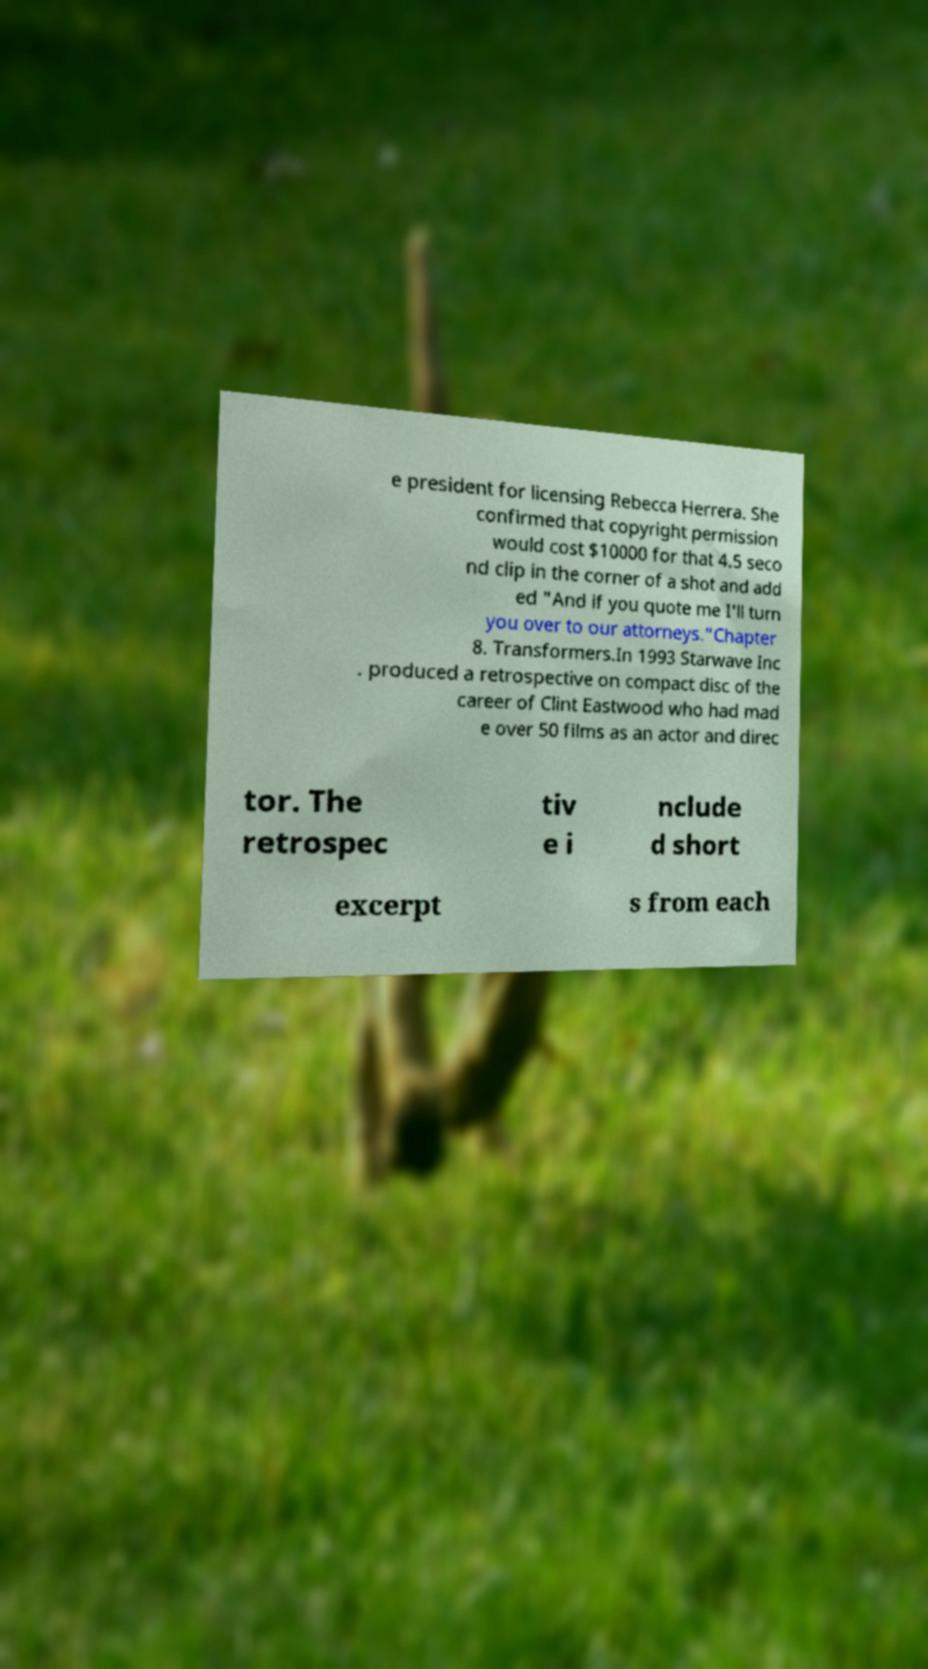Can you accurately transcribe the text from the provided image for me? e president for licensing Rebecca Herrera. She confirmed that copyright permission would cost $10000 for that 4.5 seco nd clip in the corner of a shot and add ed "And if you quote me I'll turn you over to our attorneys."Chapter 8. Transformers.In 1993 Starwave Inc . produced a retrospective on compact disc of the career of Clint Eastwood who had mad e over 50 films as an actor and direc tor. The retrospec tiv e i nclude d short excerpt s from each 